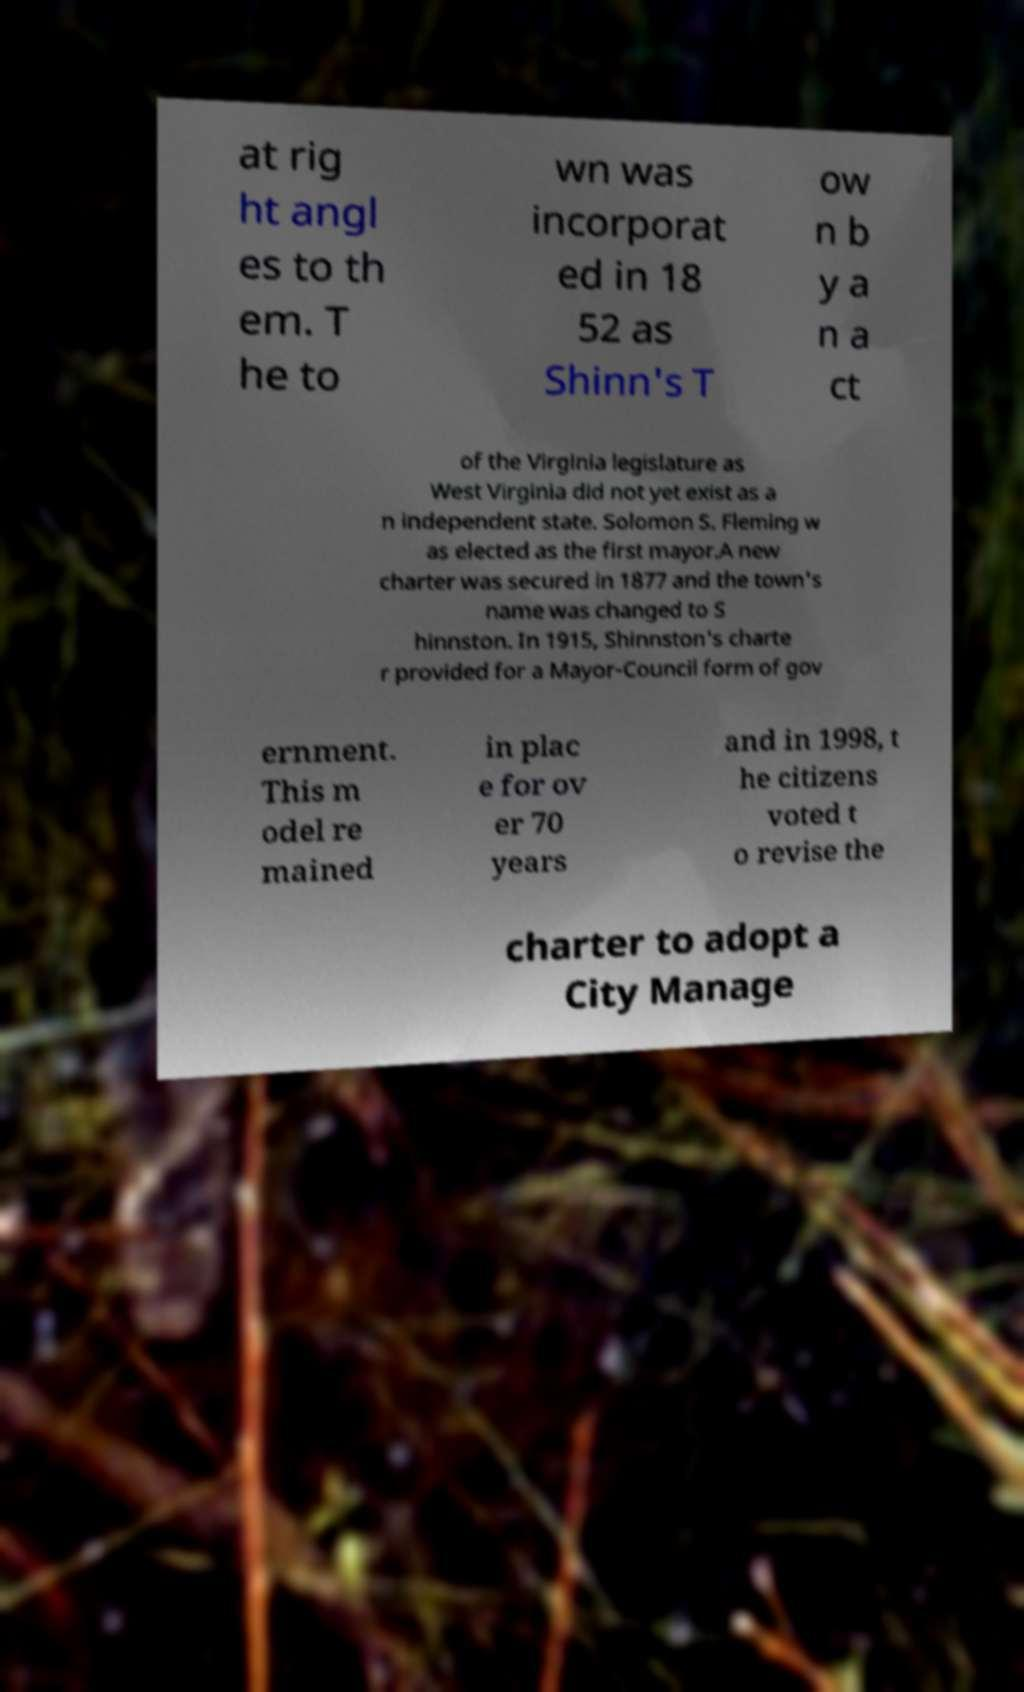Can you accurately transcribe the text from the provided image for me? at rig ht angl es to th em. T he to wn was incorporat ed in 18 52 as Shinn's T ow n b y a n a ct of the Virginia legislature as West Virginia did not yet exist as a n independent state. Solomon S. Fleming w as elected as the first mayor.A new charter was secured in 1877 and the town's name was changed to S hinnston. In 1915, Shinnston's charte r provided for a Mayor-Council form of gov ernment. This m odel re mained in plac e for ov er 70 years and in 1998, t he citizens voted t o revise the charter to adopt a City Manage 